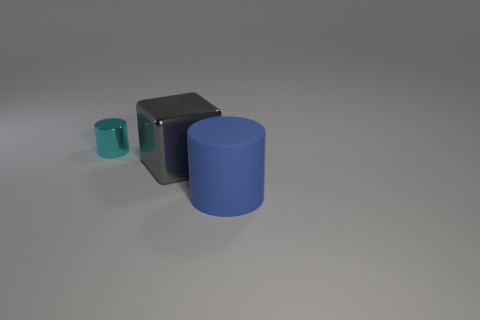Can you speculate on the sizes of these objects relative to each other? Certainly, the objects shown exhibit a descending scale in size, with the blue cylinder being the largest, the black cube of intermediate size, and the tiny cyan cylinder as the smallest. This gradation in scale might suggest a deliberate arrangement for a visual study of proportion and contrast. Could you guess their comparative sizes in terms of a common item, like a pencil? Given the visual cues and assuming no distortion, the blue cylinder could be approximately the height of a standard pencil, the black cube slightly shorter, while the small cyan cylinder may measure around a third of the pencil's length, providing a tangible point of reference for their sizes. 